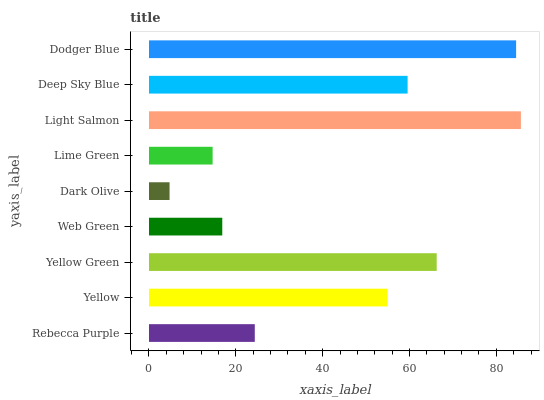Is Dark Olive the minimum?
Answer yes or no. Yes. Is Light Salmon the maximum?
Answer yes or no. Yes. Is Yellow the minimum?
Answer yes or no. No. Is Yellow the maximum?
Answer yes or no. No. Is Yellow greater than Rebecca Purple?
Answer yes or no. Yes. Is Rebecca Purple less than Yellow?
Answer yes or no. Yes. Is Rebecca Purple greater than Yellow?
Answer yes or no. No. Is Yellow less than Rebecca Purple?
Answer yes or no. No. Is Yellow the high median?
Answer yes or no. Yes. Is Yellow the low median?
Answer yes or no. Yes. Is Rebecca Purple the high median?
Answer yes or no. No. Is Lime Green the low median?
Answer yes or no. No. 